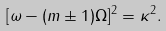Convert formula to latex. <formula><loc_0><loc_0><loc_500><loc_500>[ \omega - ( m \pm 1 ) \Omega ] ^ { 2 } = \kappa ^ { 2 } .</formula> 